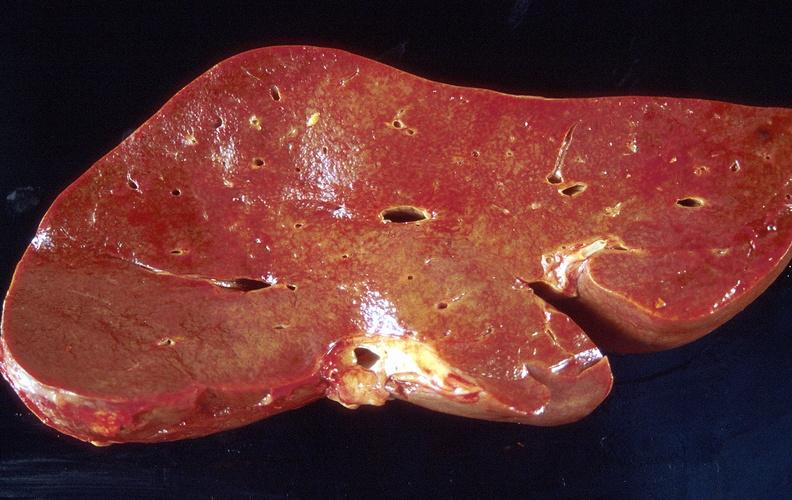does coronary artery show amyloid, liver, spleen, and kidney?
Answer the question using a single word or phrase. No 